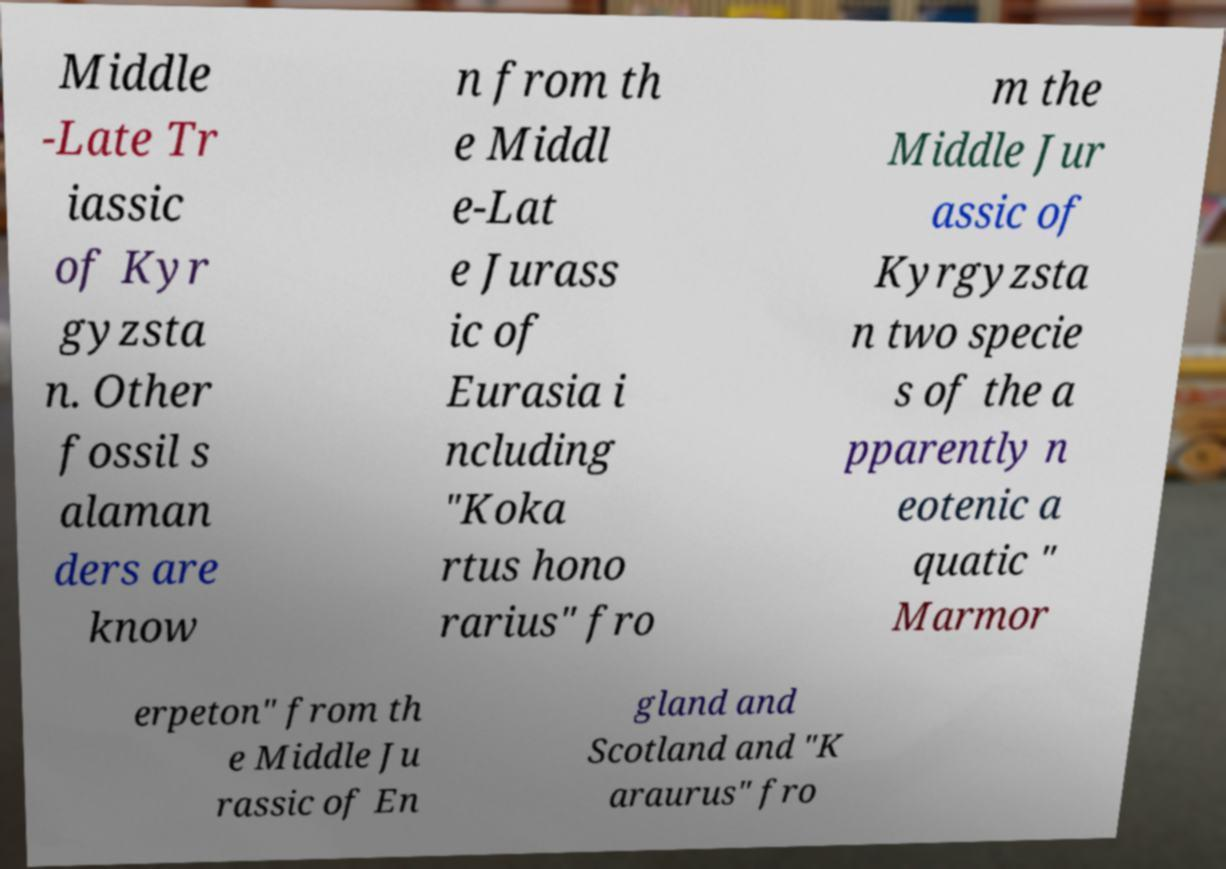For documentation purposes, I need the text within this image transcribed. Could you provide that? Middle -Late Tr iassic of Kyr gyzsta n. Other fossil s alaman ders are know n from th e Middl e-Lat e Jurass ic of Eurasia i ncluding "Koka rtus hono rarius" fro m the Middle Jur assic of Kyrgyzsta n two specie s of the a pparently n eotenic a quatic " Marmor erpeton" from th e Middle Ju rassic of En gland and Scotland and "K araurus" fro 